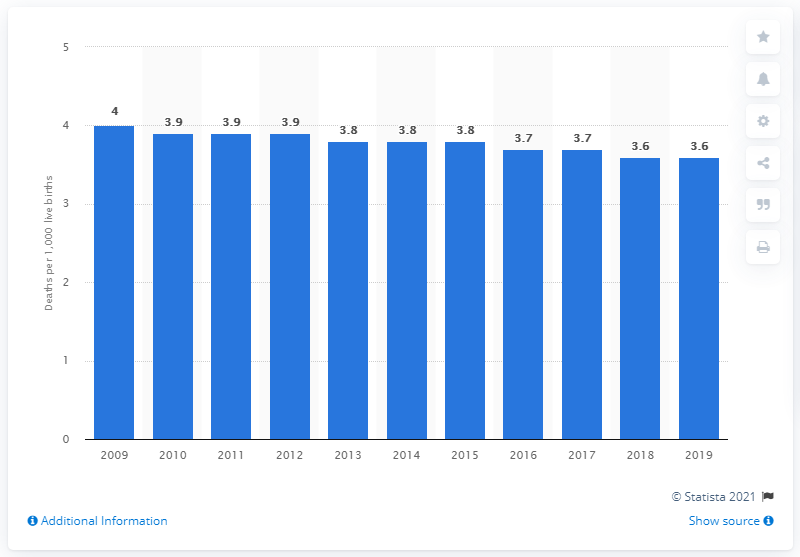Outline some significant characteristics in this image. In 2019, the infant mortality rate in Switzerland was 3.6 deaths per 1,000 live births. 